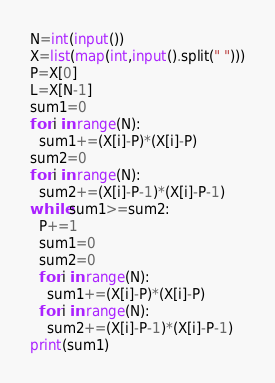Convert code to text. <code><loc_0><loc_0><loc_500><loc_500><_Python_>N=int(input())
X=list(map(int,input().split(" ")))
P=X[0]
L=X[N-1]
sum1=0
for i in range(N):
  sum1+=(X[i]-P)*(X[i]-P)
sum2=0
for i in range(N):
  sum2+=(X[i]-P-1)*(X[i]-P-1)
while sum1>=sum2:
  P+=1
  sum1=0
  sum2=0
  for i in range(N):
    sum1+=(X[i]-P)*(X[i]-P)
  for i in range(N):
    sum2+=(X[i]-P-1)*(X[i]-P-1)
print(sum1)</code> 